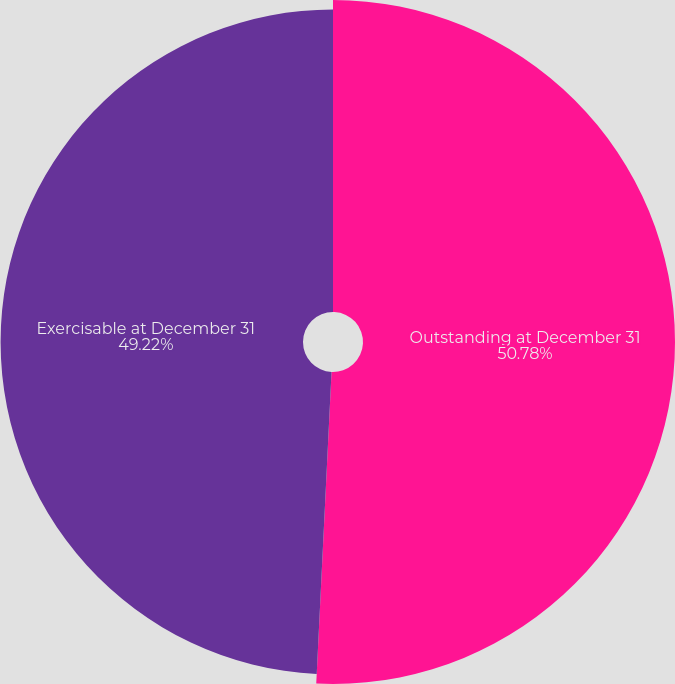<chart> <loc_0><loc_0><loc_500><loc_500><pie_chart><fcel>Outstanding at December 31<fcel>Exercisable at December 31<nl><fcel>50.78%<fcel>49.22%<nl></chart> 